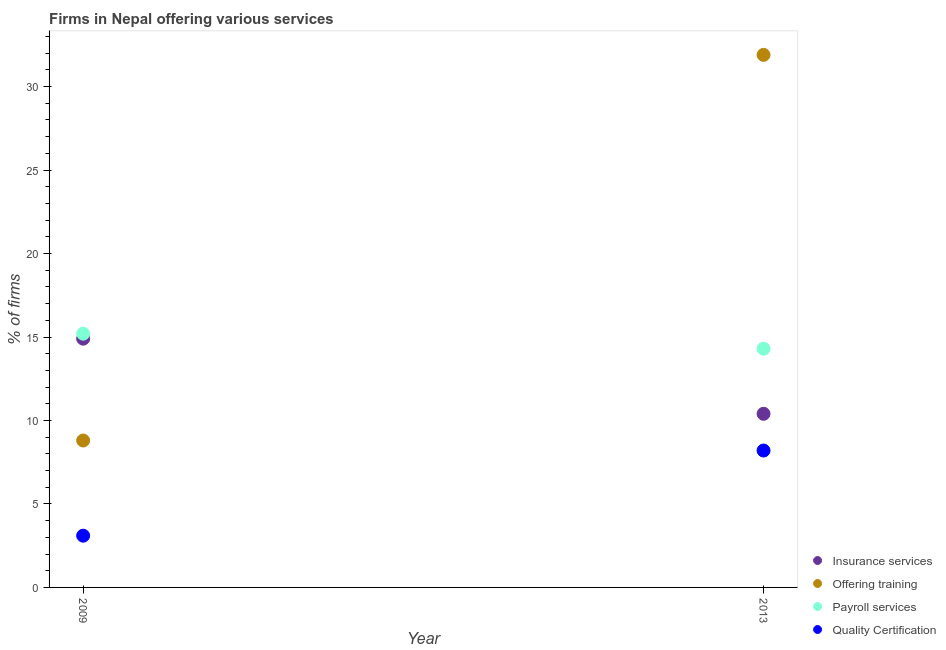Is the number of dotlines equal to the number of legend labels?
Give a very brief answer. Yes. What is the percentage of firms offering insurance services in 2013?
Offer a terse response. 10.4. In which year was the percentage of firms offering quality certification maximum?
Offer a terse response. 2013. What is the total percentage of firms offering payroll services in the graph?
Make the answer very short. 29.5. What is the difference between the percentage of firms offering quality certification in 2009 and that in 2013?
Give a very brief answer. -5.1. What is the difference between the percentage of firms offering quality certification in 2013 and the percentage of firms offering insurance services in 2009?
Ensure brevity in your answer.  -6.7. What is the average percentage of firms offering payroll services per year?
Your answer should be very brief. 14.75. In the year 2013, what is the difference between the percentage of firms offering quality certification and percentage of firms offering payroll services?
Give a very brief answer. -6.1. In how many years, is the percentage of firms offering payroll services greater than 31 %?
Your answer should be compact. 0. What is the ratio of the percentage of firms offering quality certification in 2009 to that in 2013?
Provide a succinct answer. 0.38. Is it the case that in every year, the sum of the percentage of firms offering training and percentage of firms offering payroll services is greater than the sum of percentage of firms offering insurance services and percentage of firms offering quality certification?
Ensure brevity in your answer.  No. Is the percentage of firms offering quality certification strictly greater than the percentage of firms offering insurance services over the years?
Offer a very short reply. No. How many dotlines are there?
Make the answer very short. 4. Are the values on the major ticks of Y-axis written in scientific E-notation?
Offer a terse response. No. Does the graph contain grids?
Your answer should be very brief. No. How many legend labels are there?
Your answer should be compact. 4. How are the legend labels stacked?
Your response must be concise. Vertical. What is the title of the graph?
Your answer should be compact. Firms in Nepal offering various services . What is the label or title of the X-axis?
Give a very brief answer. Year. What is the label or title of the Y-axis?
Offer a terse response. % of firms. What is the % of firms of Insurance services in 2009?
Your answer should be very brief. 14.9. What is the % of firms of Offering training in 2009?
Offer a terse response. 8.8. What is the % of firms in Insurance services in 2013?
Your answer should be very brief. 10.4. What is the % of firms of Offering training in 2013?
Your answer should be very brief. 31.9. What is the % of firms of Payroll services in 2013?
Your answer should be very brief. 14.3. What is the % of firms in Quality Certification in 2013?
Keep it short and to the point. 8.2. Across all years, what is the maximum % of firms in Insurance services?
Make the answer very short. 14.9. Across all years, what is the maximum % of firms in Offering training?
Your answer should be compact. 31.9. Across all years, what is the maximum % of firms of Payroll services?
Offer a very short reply. 15.2. Across all years, what is the maximum % of firms of Quality Certification?
Your answer should be compact. 8.2. Across all years, what is the minimum % of firms of Quality Certification?
Offer a terse response. 3.1. What is the total % of firms in Insurance services in the graph?
Provide a succinct answer. 25.3. What is the total % of firms in Offering training in the graph?
Your answer should be compact. 40.7. What is the total % of firms of Payroll services in the graph?
Provide a short and direct response. 29.5. What is the difference between the % of firms of Offering training in 2009 and that in 2013?
Your response must be concise. -23.1. What is the difference between the % of firms in Offering training in 2009 and the % of firms in Quality Certification in 2013?
Offer a terse response. 0.6. What is the difference between the % of firms in Payroll services in 2009 and the % of firms in Quality Certification in 2013?
Give a very brief answer. 7. What is the average % of firms in Insurance services per year?
Provide a succinct answer. 12.65. What is the average % of firms of Offering training per year?
Your answer should be compact. 20.35. What is the average % of firms in Payroll services per year?
Your answer should be very brief. 14.75. What is the average % of firms of Quality Certification per year?
Offer a terse response. 5.65. In the year 2009, what is the difference between the % of firms of Insurance services and % of firms of Offering training?
Provide a succinct answer. 6.1. In the year 2009, what is the difference between the % of firms in Insurance services and % of firms in Payroll services?
Offer a very short reply. -0.3. In the year 2009, what is the difference between the % of firms in Offering training and % of firms in Payroll services?
Your answer should be compact. -6.4. In the year 2009, what is the difference between the % of firms of Offering training and % of firms of Quality Certification?
Ensure brevity in your answer.  5.7. In the year 2013, what is the difference between the % of firms of Insurance services and % of firms of Offering training?
Your answer should be very brief. -21.5. In the year 2013, what is the difference between the % of firms in Insurance services and % of firms in Quality Certification?
Provide a short and direct response. 2.2. In the year 2013, what is the difference between the % of firms in Offering training and % of firms in Quality Certification?
Your answer should be very brief. 23.7. What is the ratio of the % of firms of Insurance services in 2009 to that in 2013?
Make the answer very short. 1.43. What is the ratio of the % of firms in Offering training in 2009 to that in 2013?
Offer a very short reply. 0.28. What is the ratio of the % of firms in Payroll services in 2009 to that in 2013?
Provide a short and direct response. 1.06. What is the ratio of the % of firms of Quality Certification in 2009 to that in 2013?
Your answer should be very brief. 0.38. What is the difference between the highest and the second highest % of firms in Insurance services?
Give a very brief answer. 4.5. What is the difference between the highest and the second highest % of firms of Offering training?
Provide a short and direct response. 23.1. What is the difference between the highest and the second highest % of firms of Payroll services?
Your response must be concise. 0.9. What is the difference between the highest and the lowest % of firms of Insurance services?
Ensure brevity in your answer.  4.5. What is the difference between the highest and the lowest % of firms in Offering training?
Offer a terse response. 23.1. What is the difference between the highest and the lowest % of firms of Quality Certification?
Provide a succinct answer. 5.1. 